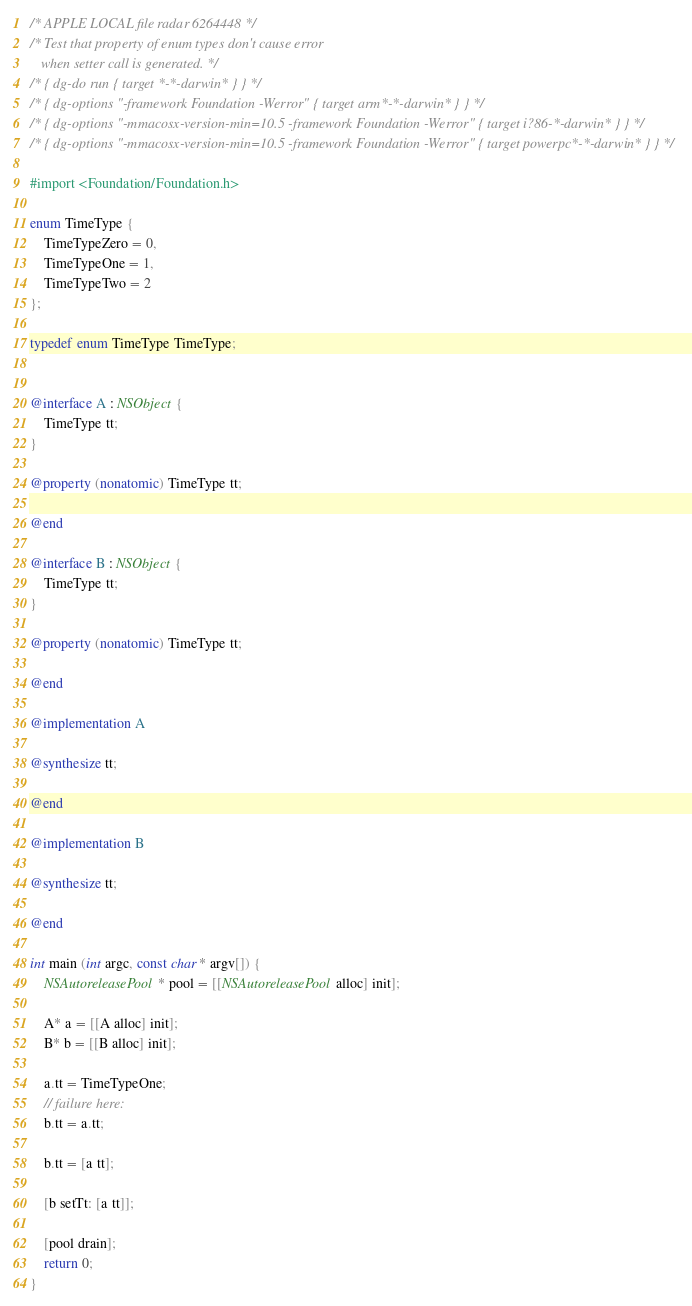Convert code to text. <code><loc_0><loc_0><loc_500><loc_500><_ObjectiveC_>/* APPLE LOCAL file radar 6264448 */
/* Test that property of enum types don't cause error
   when setter call is generated. */
/* { dg-do run { target *-*-darwin* } } */ 
/* { dg-options "-framework Foundation -Werror" { target arm*-*-darwin* } } */
/* { dg-options "-mmacosx-version-min=10.5 -framework Foundation -Werror" { target i?86-*-darwin* } } */
/* { dg-options "-mmacosx-version-min=10.5 -framework Foundation -Werror" { target powerpc*-*-darwin* } } */

#import <Foundation/Foundation.h>

enum TimeType {
    TimeTypeZero = 0,
    TimeTypeOne = 1,
    TimeTypeTwo = 2
};

typedef enum TimeType TimeType;
 

@interface A : NSObject { 
    TimeType tt; 
}

@property (nonatomic) TimeType tt;

@end

@interface B : NSObject { 
    TimeType tt; 
}

@property (nonatomic) TimeType tt;

@end

@implementation A

@synthesize tt;

@end

@implementation B

@synthesize tt;

@end

int main (int argc, const char * argv[]) {
    NSAutoreleasePool * pool = [[NSAutoreleasePool alloc] init];
    
    A* a = [[A alloc] init];
    B* b = [[B alloc] init];
    
    a.tt = TimeTypeOne;
    // failure here:
    b.tt = a.tt;
    
    b.tt = [a tt];
    
    [b setTt: [a tt]];

    [pool drain];
    return 0;
}
</code> 